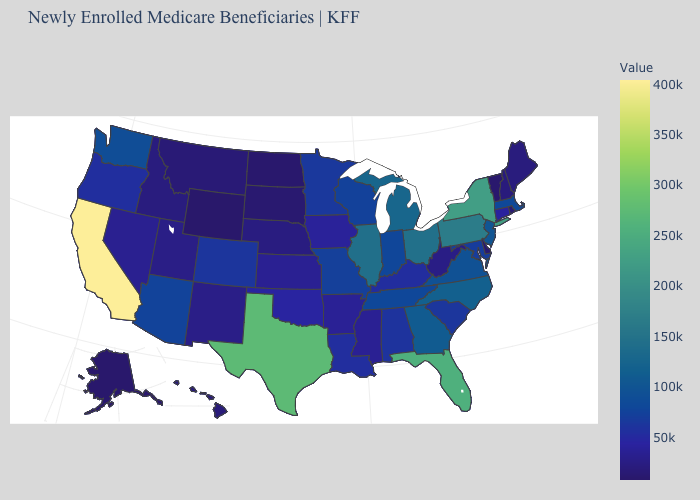Among the states that border Kentucky , does Ohio have the highest value?
Keep it brief. Yes. Among the states that border Vermont , which have the lowest value?
Keep it brief. New Hampshire. Does Wisconsin have the lowest value in the USA?
Quick response, please. No. Among the states that border Arkansas , which have the highest value?
Short answer required. Texas. 